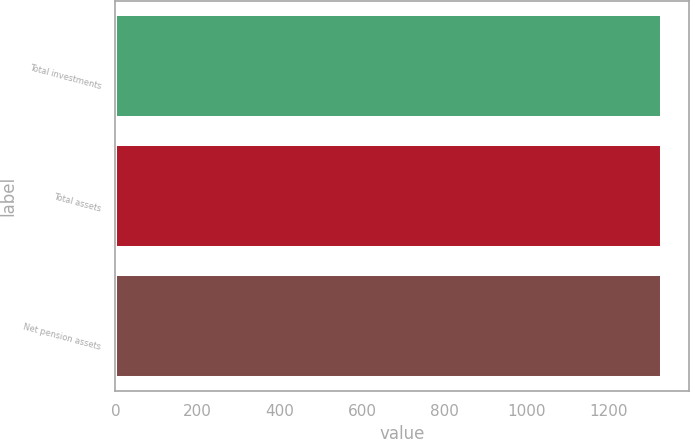Convert chart. <chart><loc_0><loc_0><loc_500><loc_500><bar_chart><fcel>Total investments<fcel>Total assets<fcel>Net pension assets<nl><fcel>1328<fcel>1328.1<fcel>1328.2<nl></chart> 